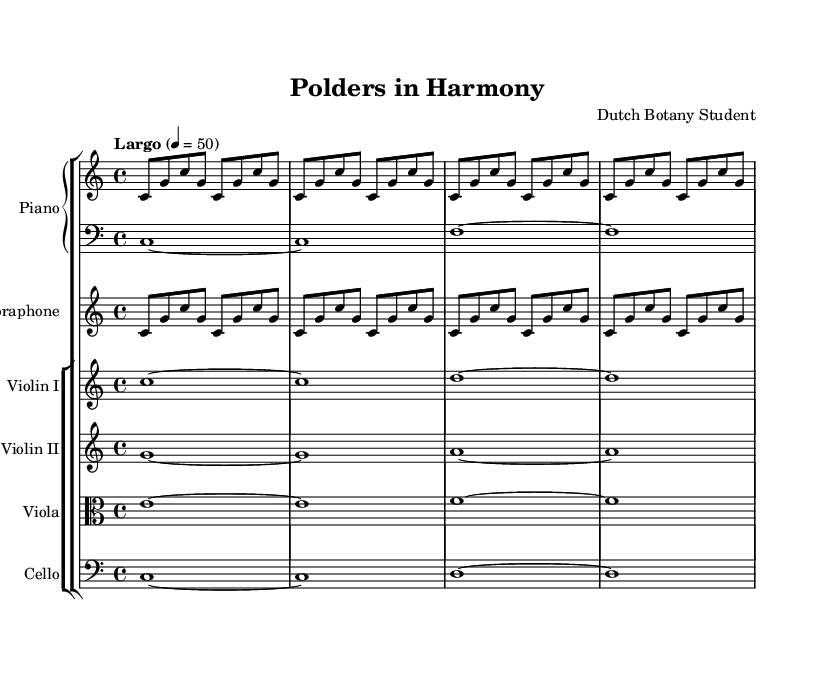What is the title of this composition? The title is found in the header section of the sheet music, clearly labeled as "Polders in Harmony."
Answer: Polders in Harmony What is the time signature of this piece? The time signature is indicated at the beginning of the score, represented as 4/4, meaning there are four beats in each measure.
Answer: 4/4 What is the tempo marking for this piece? The tempo marking "Largo" is seen at the beginning, which suggests a slow tempo, specifically indicating a quarter note equals 50 beats per minute.
Answer: Largo Which instruments are involved in this composition? The composition includes a Piano, Vibraphone, Violin I, Violin II, Viola, and Cello, as listed in the staff groupings.
Answer: Piano, Vibraphone, Violin I, Violin II, Viola, Cello How many measures are repeated in the right hand of the piano? The right hand part of the piano features the same sequence repeated 4 times, as indicated by the "repeat unfold 4" directive.
Answer: 4 What is the rhythmic pattern of the left hand in the piano? The left hand plays whole notes (c1, f1) in the pattern of sustaining each note for the entire measure, which provides a solid harmonic foundation.
Answer: Whole notes Which note is sustained the longest in the first violin part? The first violin part features the note "c" held for a whole note duration, sustained over different measures to create a lyrical quality.
Answer: c 